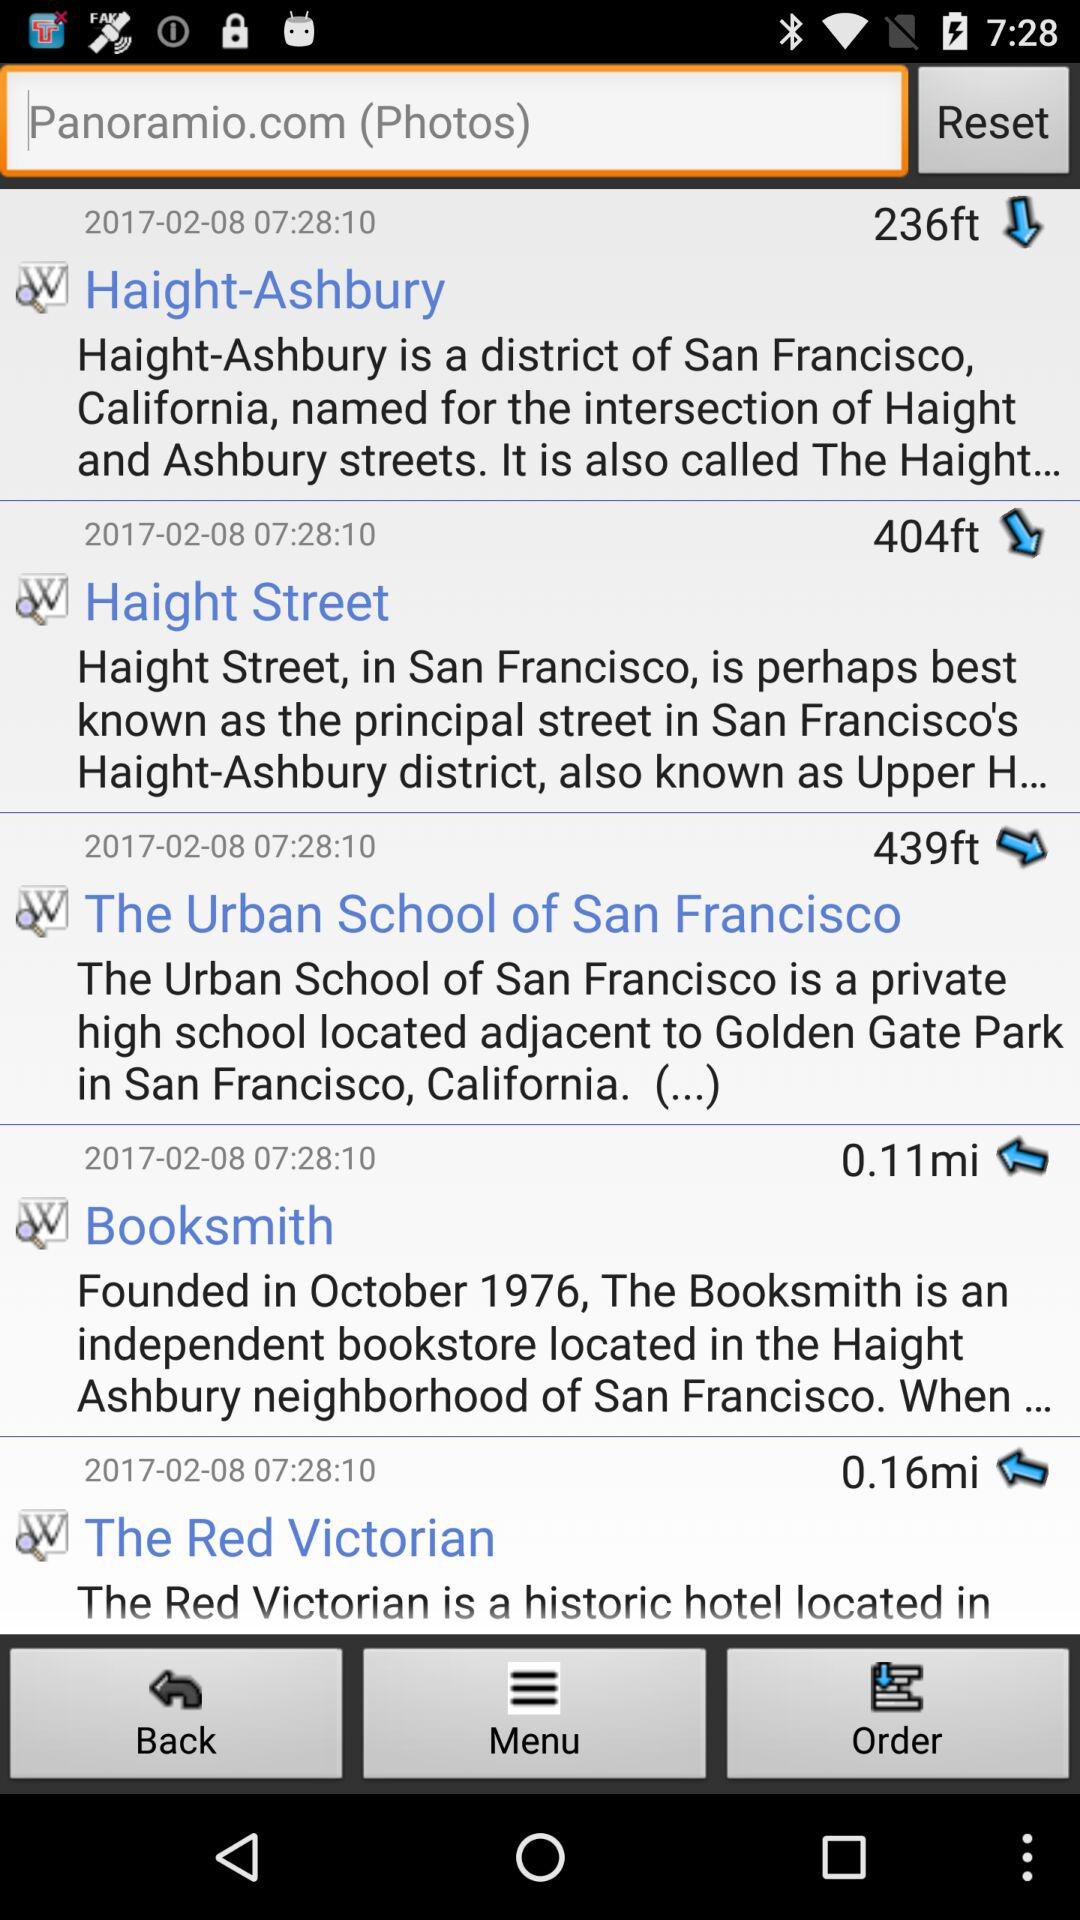What is the district of San Francisco? The district is Haight-Ashbury. 